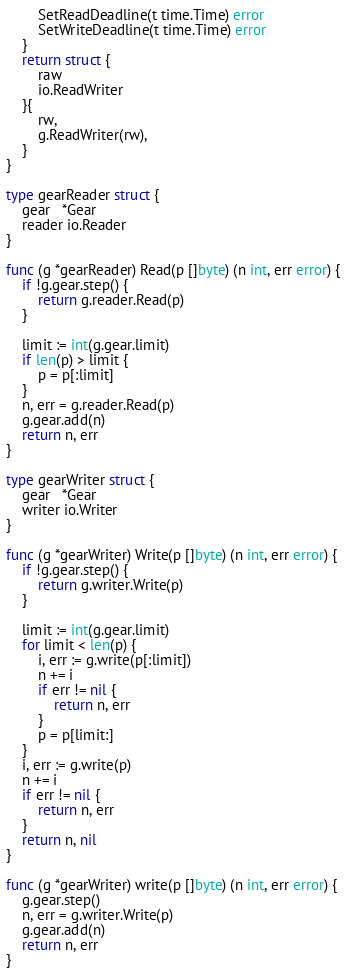Convert code to text. <code><loc_0><loc_0><loc_500><loc_500><_Go_>		SetReadDeadline(t time.Time) error
		SetWriteDeadline(t time.Time) error
	}
	return struct {
		raw
		io.ReadWriter
	}{
		rw,
		g.ReadWriter(rw),
	}
}

type gearReader struct {
	gear   *Gear
	reader io.Reader
}

func (g *gearReader) Read(p []byte) (n int, err error) {
	if !g.gear.step() {
		return g.reader.Read(p)
	}

	limit := int(g.gear.limit)
	if len(p) > limit {
		p = p[:limit]
	}
	n, err = g.reader.Read(p)
	g.gear.add(n)
	return n, err
}

type gearWriter struct {
	gear   *Gear
	writer io.Writer
}

func (g *gearWriter) Write(p []byte) (n int, err error) {
	if !g.gear.step() {
		return g.writer.Write(p)
	}

	limit := int(g.gear.limit)
	for limit < len(p) {
		i, err := g.write(p[:limit])
		n += i
		if err != nil {
			return n, err
		}
		p = p[limit:]
	}
	i, err := g.write(p)
	n += i
	if err != nil {
		return n, err
	}
	return n, nil
}

func (g *gearWriter) write(p []byte) (n int, err error) {
	g.gear.step()
	n, err = g.writer.Write(p)
	g.gear.add(n)
	return n, err
}
</code> 